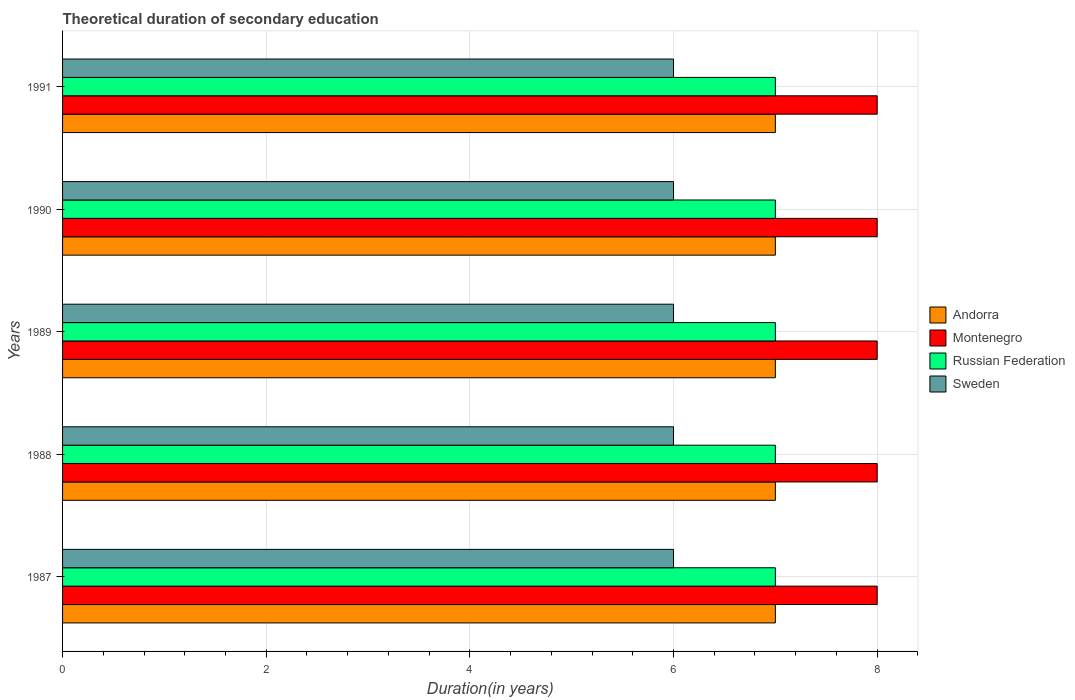How many different coloured bars are there?
Your response must be concise. 4. How many bars are there on the 5th tick from the top?
Give a very brief answer. 4. What is the label of the 1st group of bars from the top?
Ensure brevity in your answer.  1991. What is the total theoretical duration of secondary education in Russian Federation in 1991?
Your answer should be very brief. 7. Across all years, what is the maximum total theoretical duration of secondary education in Sweden?
Offer a very short reply. 6. Across all years, what is the minimum total theoretical duration of secondary education in Montenegro?
Give a very brief answer. 8. In which year was the total theoretical duration of secondary education in Russian Federation minimum?
Give a very brief answer. 1987. What is the total total theoretical duration of secondary education in Russian Federation in the graph?
Your answer should be compact. 35. What is the difference between the total theoretical duration of secondary education in Montenegro in 1990 and that in 1991?
Offer a terse response. 0. What is the difference between the total theoretical duration of secondary education in Andorra in 1990 and the total theoretical duration of secondary education in Russian Federation in 1987?
Your answer should be very brief. 0. In the year 1990, what is the difference between the total theoretical duration of secondary education in Sweden and total theoretical duration of secondary education in Andorra?
Your response must be concise. -1. Is the difference between the total theoretical duration of secondary education in Sweden in 1987 and 1989 greater than the difference between the total theoretical duration of secondary education in Andorra in 1987 and 1989?
Keep it short and to the point. No. What does the 4th bar from the top in 1987 represents?
Provide a short and direct response. Andorra. What does the 3rd bar from the bottom in 1987 represents?
Your answer should be compact. Russian Federation. Are all the bars in the graph horizontal?
Your answer should be very brief. Yes. How many years are there in the graph?
Your answer should be compact. 5. What is the difference between two consecutive major ticks on the X-axis?
Offer a very short reply. 2. Are the values on the major ticks of X-axis written in scientific E-notation?
Keep it short and to the point. No. Does the graph contain grids?
Provide a short and direct response. Yes. Where does the legend appear in the graph?
Provide a succinct answer. Center right. How many legend labels are there?
Your answer should be compact. 4. How are the legend labels stacked?
Ensure brevity in your answer.  Vertical. What is the title of the graph?
Your answer should be compact. Theoretical duration of secondary education. What is the label or title of the X-axis?
Your answer should be compact. Duration(in years). What is the Duration(in years) in Andorra in 1987?
Offer a terse response. 7. What is the Duration(in years) of Montenegro in 1987?
Ensure brevity in your answer.  8. What is the Duration(in years) of Russian Federation in 1988?
Keep it short and to the point. 7. What is the Duration(in years) in Sweden in 1988?
Your response must be concise. 6. What is the Duration(in years) of Montenegro in 1989?
Provide a succinct answer. 8. What is the Duration(in years) in Andorra in 1990?
Provide a short and direct response. 7. What is the Duration(in years) in Montenegro in 1990?
Provide a succinct answer. 8. What is the Duration(in years) in Russian Federation in 1990?
Provide a succinct answer. 7. What is the Duration(in years) in Sweden in 1990?
Your answer should be very brief. 6. What is the Duration(in years) of Montenegro in 1991?
Provide a short and direct response. 8. What is the Duration(in years) of Russian Federation in 1991?
Make the answer very short. 7. What is the Duration(in years) in Sweden in 1991?
Give a very brief answer. 6. Across all years, what is the maximum Duration(in years) of Russian Federation?
Offer a terse response. 7. Across all years, what is the maximum Duration(in years) of Sweden?
Make the answer very short. 6. Across all years, what is the minimum Duration(in years) in Montenegro?
Keep it short and to the point. 8. Across all years, what is the minimum Duration(in years) of Russian Federation?
Keep it short and to the point. 7. What is the total Duration(in years) in Andorra in the graph?
Offer a very short reply. 35. What is the total Duration(in years) in Montenegro in the graph?
Your answer should be compact. 40. What is the total Duration(in years) in Sweden in the graph?
Keep it short and to the point. 30. What is the difference between the Duration(in years) in Russian Federation in 1987 and that in 1988?
Offer a very short reply. 0. What is the difference between the Duration(in years) of Sweden in 1987 and that in 1988?
Make the answer very short. 0. What is the difference between the Duration(in years) of Montenegro in 1987 and that in 1989?
Ensure brevity in your answer.  0. What is the difference between the Duration(in years) in Sweden in 1987 and that in 1989?
Your answer should be very brief. 0. What is the difference between the Duration(in years) in Sweden in 1987 and that in 1991?
Offer a terse response. 0. What is the difference between the Duration(in years) in Andorra in 1988 and that in 1989?
Provide a short and direct response. 0. What is the difference between the Duration(in years) of Montenegro in 1988 and that in 1989?
Your response must be concise. 0. What is the difference between the Duration(in years) of Russian Federation in 1988 and that in 1989?
Ensure brevity in your answer.  0. What is the difference between the Duration(in years) in Sweden in 1988 and that in 1989?
Keep it short and to the point. 0. What is the difference between the Duration(in years) of Andorra in 1988 and that in 1990?
Make the answer very short. 0. What is the difference between the Duration(in years) in Sweden in 1988 and that in 1990?
Your response must be concise. 0. What is the difference between the Duration(in years) in Andorra in 1988 and that in 1991?
Keep it short and to the point. 0. What is the difference between the Duration(in years) in Sweden in 1988 and that in 1991?
Provide a short and direct response. 0. What is the difference between the Duration(in years) in Sweden in 1989 and that in 1990?
Give a very brief answer. 0. What is the difference between the Duration(in years) in Russian Federation in 1989 and that in 1991?
Your answer should be very brief. 0. What is the difference between the Duration(in years) of Montenegro in 1990 and that in 1991?
Keep it short and to the point. 0. What is the difference between the Duration(in years) of Andorra in 1987 and the Duration(in years) of Russian Federation in 1988?
Your response must be concise. 0. What is the difference between the Duration(in years) of Andorra in 1987 and the Duration(in years) of Sweden in 1988?
Ensure brevity in your answer.  1. What is the difference between the Duration(in years) of Montenegro in 1987 and the Duration(in years) of Russian Federation in 1988?
Give a very brief answer. 1. What is the difference between the Duration(in years) of Montenegro in 1987 and the Duration(in years) of Sweden in 1988?
Your answer should be very brief. 2. What is the difference between the Duration(in years) of Russian Federation in 1987 and the Duration(in years) of Sweden in 1988?
Your answer should be compact. 1. What is the difference between the Duration(in years) in Andorra in 1987 and the Duration(in years) in Montenegro in 1989?
Keep it short and to the point. -1. What is the difference between the Duration(in years) in Andorra in 1987 and the Duration(in years) in Sweden in 1989?
Keep it short and to the point. 1. What is the difference between the Duration(in years) of Montenegro in 1987 and the Duration(in years) of Russian Federation in 1989?
Offer a very short reply. 1. What is the difference between the Duration(in years) of Montenegro in 1987 and the Duration(in years) of Russian Federation in 1990?
Offer a terse response. 1. What is the difference between the Duration(in years) of Montenegro in 1987 and the Duration(in years) of Sweden in 1990?
Your response must be concise. 2. What is the difference between the Duration(in years) of Russian Federation in 1987 and the Duration(in years) of Sweden in 1990?
Offer a terse response. 1. What is the difference between the Duration(in years) of Andorra in 1987 and the Duration(in years) of Russian Federation in 1991?
Offer a terse response. 0. What is the difference between the Duration(in years) in Montenegro in 1987 and the Duration(in years) in Russian Federation in 1991?
Ensure brevity in your answer.  1. What is the difference between the Duration(in years) of Andorra in 1988 and the Duration(in years) of Sweden in 1989?
Make the answer very short. 1. What is the difference between the Duration(in years) in Montenegro in 1988 and the Duration(in years) in Sweden in 1989?
Offer a terse response. 2. What is the difference between the Duration(in years) in Russian Federation in 1988 and the Duration(in years) in Sweden in 1989?
Make the answer very short. 1. What is the difference between the Duration(in years) in Andorra in 1988 and the Duration(in years) in Montenegro in 1990?
Your response must be concise. -1. What is the difference between the Duration(in years) of Andorra in 1988 and the Duration(in years) of Russian Federation in 1990?
Your answer should be compact. 0. What is the difference between the Duration(in years) in Andorra in 1988 and the Duration(in years) in Sweden in 1990?
Offer a very short reply. 1. What is the difference between the Duration(in years) in Montenegro in 1988 and the Duration(in years) in Russian Federation in 1990?
Your answer should be compact. 1. What is the difference between the Duration(in years) in Montenegro in 1988 and the Duration(in years) in Sweden in 1990?
Give a very brief answer. 2. What is the difference between the Duration(in years) in Russian Federation in 1988 and the Duration(in years) in Sweden in 1990?
Offer a very short reply. 1. What is the difference between the Duration(in years) in Montenegro in 1988 and the Duration(in years) in Sweden in 1991?
Your answer should be very brief. 2. What is the difference between the Duration(in years) of Andorra in 1989 and the Duration(in years) of Montenegro in 1990?
Offer a very short reply. -1. What is the difference between the Duration(in years) in Andorra in 1989 and the Duration(in years) in Sweden in 1990?
Make the answer very short. 1. What is the difference between the Duration(in years) of Andorra in 1989 and the Duration(in years) of Russian Federation in 1991?
Provide a short and direct response. 0. What is the difference between the Duration(in years) in Andorra in 1989 and the Duration(in years) in Sweden in 1991?
Make the answer very short. 1. What is the difference between the Duration(in years) in Montenegro in 1989 and the Duration(in years) in Russian Federation in 1991?
Your response must be concise. 1. What is the difference between the Duration(in years) in Montenegro in 1989 and the Duration(in years) in Sweden in 1991?
Keep it short and to the point. 2. What is the difference between the Duration(in years) in Andorra in 1990 and the Duration(in years) in Russian Federation in 1991?
Your response must be concise. 0. What is the difference between the Duration(in years) of Montenegro in 1990 and the Duration(in years) of Russian Federation in 1991?
Give a very brief answer. 1. What is the difference between the Duration(in years) of Montenegro in 1990 and the Duration(in years) of Sweden in 1991?
Provide a short and direct response. 2. What is the average Duration(in years) of Andorra per year?
Give a very brief answer. 7. What is the average Duration(in years) in Montenegro per year?
Keep it short and to the point. 8. In the year 1987, what is the difference between the Duration(in years) in Montenegro and Duration(in years) in Sweden?
Make the answer very short. 2. In the year 1987, what is the difference between the Duration(in years) of Russian Federation and Duration(in years) of Sweden?
Make the answer very short. 1. In the year 1988, what is the difference between the Duration(in years) in Montenegro and Duration(in years) in Sweden?
Offer a very short reply. 2. In the year 1988, what is the difference between the Duration(in years) of Russian Federation and Duration(in years) of Sweden?
Provide a succinct answer. 1. In the year 1989, what is the difference between the Duration(in years) of Andorra and Duration(in years) of Sweden?
Keep it short and to the point. 1. In the year 1989, what is the difference between the Duration(in years) in Montenegro and Duration(in years) in Sweden?
Provide a short and direct response. 2. In the year 1989, what is the difference between the Duration(in years) of Russian Federation and Duration(in years) of Sweden?
Provide a short and direct response. 1. In the year 1990, what is the difference between the Duration(in years) in Andorra and Duration(in years) in Sweden?
Your response must be concise. 1. In the year 1990, what is the difference between the Duration(in years) of Montenegro and Duration(in years) of Russian Federation?
Give a very brief answer. 1. In the year 1991, what is the difference between the Duration(in years) of Andorra and Duration(in years) of Montenegro?
Offer a very short reply. -1. In the year 1991, what is the difference between the Duration(in years) of Andorra and Duration(in years) of Sweden?
Provide a succinct answer. 1. In the year 1991, what is the difference between the Duration(in years) in Russian Federation and Duration(in years) in Sweden?
Your answer should be compact. 1. What is the ratio of the Duration(in years) in Montenegro in 1987 to that in 1988?
Provide a short and direct response. 1. What is the ratio of the Duration(in years) in Andorra in 1987 to that in 1989?
Your answer should be very brief. 1. What is the ratio of the Duration(in years) of Montenegro in 1987 to that in 1989?
Provide a short and direct response. 1. What is the ratio of the Duration(in years) of Russian Federation in 1987 to that in 1989?
Keep it short and to the point. 1. What is the ratio of the Duration(in years) of Sweden in 1987 to that in 1989?
Make the answer very short. 1. What is the ratio of the Duration(in years) of Montenegro in 1987 to that in 1990?
Make the answer very short. 1. What is the ratio of the Duration(in years) in Montenegro in 1987 to that in 1991?
Offer a very short reply. 1. What is the ratio of the Duration(in years) in Russian Federation in 1987 to that in 1991?
Provide a succinct answer. 1. What is the ratio of the Duration(in years) in Andorra in 1988 to that in 1989?
Provide a short and direct response. 1. What is the ratio of the Duration(in years) of Montenegro in 1988 to that in 1989?
Offer a very short reply. 1. What is the ratio of the Duration(in years) in Russian Federation in 1988 to that in 1989?
Keep it short and to the point. 1. What is the ratio of the Duration(in years) in Sweden in 1988 to that in 1989?
Give a very brief answer. 1. What is the ratio of the Duration(in years) of Sweden in 1988 to that in 1990?
Your answer should be compact. 1. What is the ratio of the Duration(in years) in Andorra in 1988 to that in 1991?
Offer a very short reply. 1. What is the ratio of the Duration(in years) in Montenegro in 1988 to that in 1991?
Your response must be concise. 1. What is the ratio of the Duration(in years) of Sweden in 1988 to that in 1991?
Your response must be concise. 1. What is the ratio of the Duration(in years) in Montenegro in 1989 to that in 1990?
Make the answer very short. 1. What is the ratio of the Duration(in years) in Russian Federation in 1989 to that in 1990?
Your answer should be very brief. 1. What is the ratio of the Duration(in years) of Sweden in 1989 to that in 1990?
Offer a terse response. 1. What is the ratio of the Duration(in years) of Russian Federation in 1989 to that in 1991?
Your answer should be compact. 1. What is the ratio of the Duration(in years) of Sweden in 1989 to that in 1991?
Provide a short and direct response. 1. What is the ratio of the Duration(in years) in Montenegro in 1990 to that in 1991?
Offer a very short reply. 1. What is the ratio of the Duration(in years) of Russian Federation in 1990 to that in 1991?
Your answer should be very brief. 1. What is the difference between the highest and the second highest Duration(in years) of Andorra?
Give a very brief answer. 0. What is the difference between the highest and the second highest Duration(in years) in Montenegro?
Provide a short and direct response. 0. What is the difference between the highest and the second highest Duration(in years) of Sweden?
Your answer should be compact. 0. 